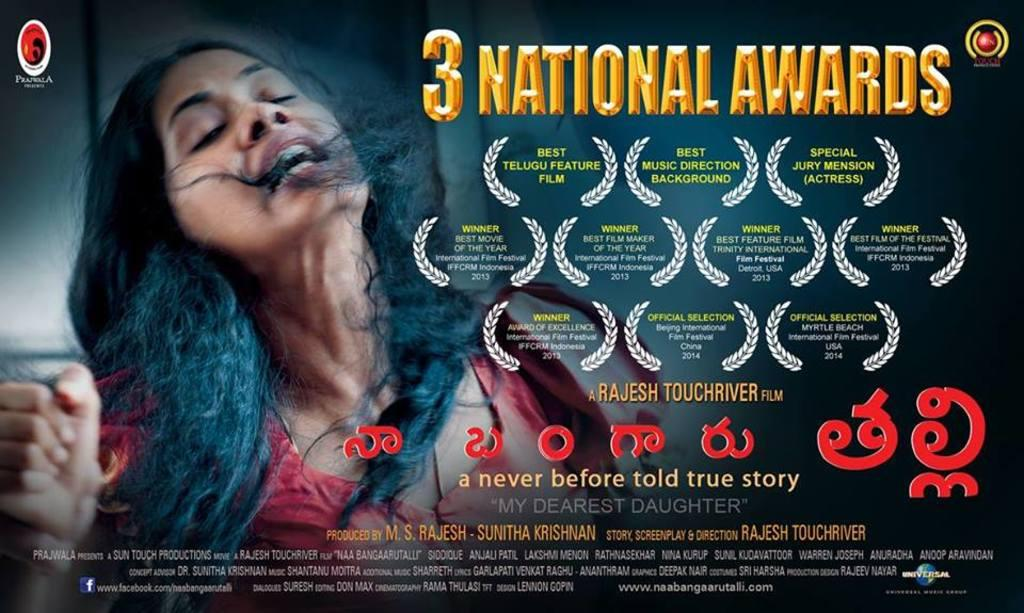<image>
Describe the image concisely. A movie poster for My Dearest Daughter which won 3 national awards. 